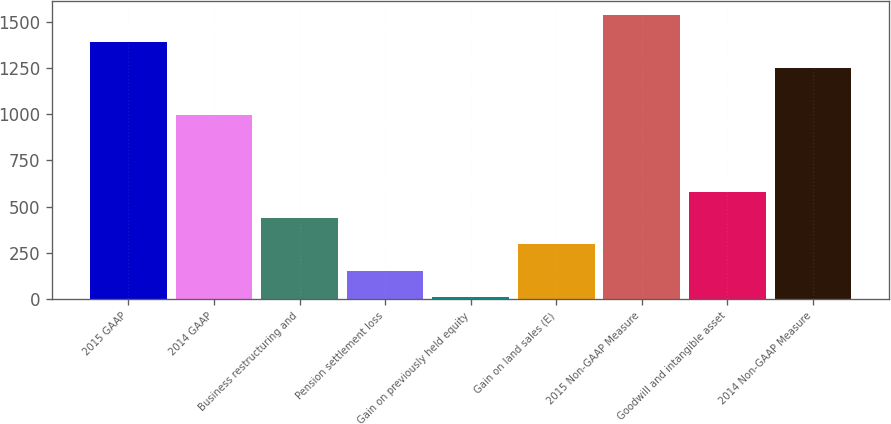Convert chart. <chart><loc_0><loc_0><loc_500><loc_500><bar_chart><fcel>2015 GAAP<fcel>2014 GAAP<fcel>Business restructuring and<fcel>Pension settlement loss<fcel>Gain on previously held equity<fcel>Gain on land sales (E)<fcel>2015 Non-GAAP Measure<fcel>Goodwill and intangible asset<fcel>2014 Non-GAAP Measure<nl><fcel>1392.76<fcel>994.6<fcel>437.98<fcel>153.46<fcel>11.2<fcel>295.72<fcel>1535.02<fcel>580.24<fcel>1250.5<nl></chart> 